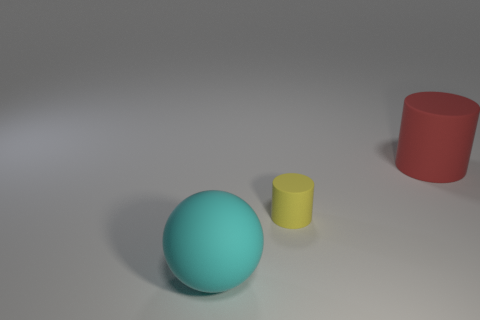Add 1 rubber cylinders. How many objects exist? 4 Subtract all cylinders. How many objects are left? 1 Add 3 big cyan rubber things. How many big cyan rubber things are left? 4 Add 1 small green metallic cylinders. How many small green metallic cylinders exist? 1 Subtract 0 gray cubes. How many objects are left? 3 Subtract all cyan rubber spheres. Subtract all small matte things. How many objects are left? 1 